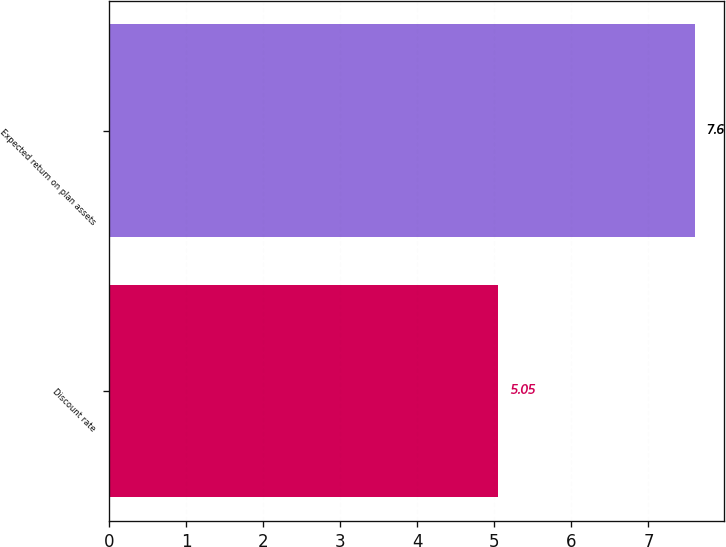Convert chart to OTSL. <chart><loc_0><loc_0><loc_500><loc_500><bar_chart><fcel>Discount rate<fcel>Expected return on plan assets<nl><fcel>5.05<fcel>7.6<nl></chart> 